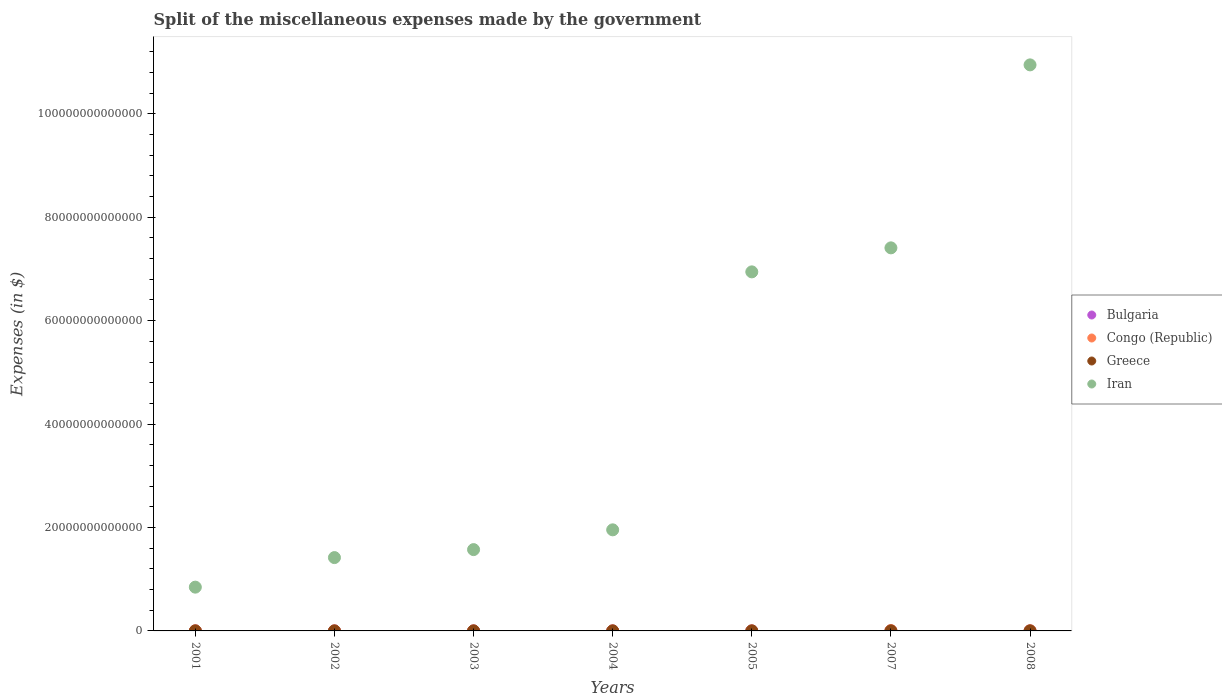What is the miscellaneous expenses made by the government in Congo (Republic) in 2005?
Offer a very short reply. 3.32e+08. Across all years, what is the maximum miscellaneous expenses made by the government in Congo (Republic)?
Your answer should be compact. 5.35e+1. Across all years, what is the minimum miscellaneous expenses made by the government in Bulgaria?
Keep it short and to the point. 1.15e+08. What is the total miscellaneous expenses made by the government in Bulgaria in the graph?
Provide a short and direct response. 3.72e+09. What is the difference between the miscellaneous expenses made by the government in Congo (Republic) in 2005 and that in 2008?
Make the answer very short. -1.84e+1. What is the difference between the miscellaneous expenses made by the government in Iran in 2007 and the miscellaneous expenses made by the government in Congo (Republic) in 2008?
Give a very brief answer. 7.41e+13. What is the average miscellaneous expenses made by the government in Congo (Republic) per year?
Provide a succinct answer. 1.38e+1. In the year 2002, what is the difference between the miscellaneous expenses made by the government in Congo (Republic) and miscellaneous expenses made by the government in Iran?
Offer a terse response. -1.42e+13. What is the ratio of the miscellaneous expenses made by the government in Bulgaria in 2003 to that in 2004?
Make the answer very short. 0.72. Is the difference between the miscellaneous expenses made by the government in Congo (Republic) in 2002 and 2004 greater than the difference between the miscellaneous expenses made by the government in Iran in 2002 and 2004?
Provide a succinct answer. Yes. What is the difference between the highest and the second highest miscellaneous expenses made by the government in Iran?
Give a very brief answer. 3.54e+13. What is the difference between the highest and the lowest miscellaneous expenses made by the government in Bulgaria?
Provide a succinct answer. 1.11e+09. In how many years, is the miscellaneous expenses made by the government in Greece greater than the average miscellaneous expenses made by the government in Greece taken over all years?
Provide a succinct answer. 3. Does the miscellaneous expenses made by the government in Congo (Republic) monotonically increase over the years?
Provide a short and direct response. No. Is the miscellaneous expenses made by the government in Greece strictly greater than the miscellaneous expenses made by the government in Congo (Republic) over the years?
Offer a very short reply. No. How many years are there in the graph?
Your answer should be very brief. 7. What is the difference between two consecutive major ticks on the Y-axis?
Provide a short and direct response. 2.00e+13. Does the graph contain any zero values?
Offer a very short reply. No. How many legend labels are there?
Keep it short and to the point. 4. What is the title of the graph?
Offer a terse response. Split of the miscellaneous expenses made by the government. What is the label or title of the Y-axis?
Your answer should be very brief. Expenses (in $). What is the Expenses (in $) in Bulgaria in 2001?
Offer a terse response. 1.15e+08. What is the Expenses (in $) in Congo (Republic) in 2001?
Offer a terse response. 1.96e+1. What is the Expenses (in $) of Greece in 2001?
Offer a terse response. 6.46e+09. What is the Expenses (in $) of Iran in 2001?
Your answer should be compact. 8.46e+12. What is the Expenses (in $) of Bulgaria in 2002?
Offer a very short reply. 2.27e+08. What is the Expenses (in $) in Congo (Republic) in 2002?
Your response must be concise. 2.75e+09. What is the Expenses (in $) in Greece in 2002?
Give a very brief answer. 5.64e+09. What is the Expenses (in $) in Iran in 2002?
Your answer should be compact. 1.42e+13. What is the Expenses (in $) of Bulgaria in 2003?
Provide a succinct answer. 2.76e+08. What is the Expenses (in $) in Congo (Republic) in 2003?
Offer a very short reply. 1.55e+09. What is the Expenses (in $) of Greece in 2003?
Keep it short and to the point. 6.39e+09. What is the Expenses (in $) of Iran in 2003?
Ensure brevity in your answer.  1.57e+13. What is the Expenses (in $) in Bulgaria in 2004?
Give a very brief answer. 3.84e+08. What is the Expenses (in $) of Congo (Republic) in 2004?
Offer a very short reply. 2.56e+08. What is the Expenses (in $) of Greece in 2004?
Give a very brief answer. 8.55e+09. What is the Expenses (in $) of Iran in 2004?
Offer a very short reply. 1.95e+13. What is the Expenses (in $) in Bulgaria in 2005?
Ensure brevity in your answer.  4.53e+08. What is the Expenses (in $) of Congo (Republic) in 2005?
Offer a terse response. 3.32e+08. What is the Expenses (in $) in Greece in 2005?
Ensure brevity in your answer.  6.98e+09. What is the Expenses (in $) of Iran in 2005?
Your answer should be very brief. 6.94e+13. What is the Expenses (in $) in Bulgaria in 2007?
Give a very brief answer. 1.05e+09. What is the Expenses (in $) in Congo (Republic) in 2007?
Make the answer very short. 5.35e+1. What is the Expenses (in $) in Greece in 2007?
Your response must be concise. 7.33e+09. What is the Expenses (in $) in Iran in 2007?
Make the answer very short. 7.41e+13. What is the Expenses (in $) of Bulgaria in 2008?
Ensure brevity in your answer.  1.22e+09. What is the Expenses (in $) of Congo (Republic) in 2008?
Offer a terse response. 1.88e+1. What is the Expenses (in $) of Greece in 2008?
Ensure brevity in your answer.  9.56e+09. What is the Expenses (in $) of Iran in 2008?
Offer a very short reply. 1.09e+14. Across all years, what is the maximum Expenses (in $) of Bulgaria?
Your answer should be compact. 1.22e+09. Across all years, what is the maximum Expenses (in $) of Congo (Republic)?
Your response must be concise. 5.35e+1. Across all years, what is the maximum Expenses (in $) of Greece?
Provide a succinct answer. 9.56e+09. Across all years, what is the maximum Expenses (in $) of Iran?
Your response must be concise. 1.09e+14. Across all years, what is the minimum Expenses (in $) of Bulgaria?
Give a very brief answer. 1.15e+08. Across all years, what is the minimum Expenses (in $) of Congo (Republic)?
Keep it short and to the point. 2.56e+08. Across all years, what is the minimum Expenses (in $) of Greece?
Your response must be concise. 5.64e+09. Across all years, what is the minimum Expenses (in $) in Iran?
Give a very brief answer. 8.46e+12. What is the total Expenses (in $) in Bulgaria in the graph?
Provide a succinct answer. 3.72e+09. What is the total Expenses (in $) of Congo (Republic) in the graph?
Offer a terse response. 9.68e+1. What is the total Expenses (in $) of Greece in the graph?
Your response must be concise. 5.09e+1. What is the total Expenses (in $) in Iran in the graph?
Keep it short and to the point. 3.11e+14. What is the difference between the Expenses (in $) in Bulgaria in 2001 and that in 2002?
Your response must be concise. -1.12e+08. What is the difference between the Expenses (in $) of Congo (Republic) in 2001 and that in 2002?
Give a very brief answer. 1.69e+1. What is the difference between the Expenses (in $) of Greece in 2001 and that in 2002?
Make the answer very short. 8.20e+08. What is the difference between the Expenses (in $) of Iran in 2001 and that in 2002?
Your response must be concise. -5.72e+12. What is the difference between the Expenses (in $) of Bulgaria in 2001 and that in 2003?
Ensure brevity in your answer.  -1.62e+08. What is the difference between the Expenses (in $) in Congo (Republic) in 2001 and that in 2003?
Your response must be concise. 1.81e+1. What is the difference between the Expenses (in $) in Greece in 2001 and that in 2003?
Ensure brevity in your answer.  7.70e+07. What is the difference between the Expenses (in $) in Iran in 2001 and that in 2003?
Offer a terse response. -7.26e+12. What is the difference between the Expenses (in $) in Bulgaria in 2001 and that in 2004?
Give a very brief answer. -2.70e+08. What is the difference between the Expenses (in $) in Congo (Republic) in 2001 and that in 2004?
Keep it short and to the point. 1.94e+1. What is the difference between the Expenses (in $) in Greece in 2001 and that in 2004?
Offer a terse response. -2.09e+09. What is the difference between the Expenses (in $) in Iran in 2001 and that in 2004?
Your answer should be very brief. -1.11e+13. What is the difference between the Expenses (in $) in Bulgaria in 2001 and that in 2005?
Your answer should be compact. -3.39e+08. What is the difference between the Expenses (in $) of Congo (Republic) in 2001 and that in 2005?
Keep it short and to the point. 1.93e+1. What is the difference between the Expenses (in $) in Greece in 2001 and that in 2005?
Provide a short and direct response. -5.20e+08. What is the difference between the Expenses (in $) in Iran in 2001 and that in 2005?
Ensure brevity in your answer.  -6.10e+13. What is the difference between the Expenses (in $) in Bulgaria in 2001 and that in 2007?
Offer a terse response. -9.34e+08. What is the difference between the Expenses (in $) in Congo (Republic) in 2001 and that in 2007?
Your answer should be very brief. -3.39e+1. What is the difference between the Expenses (in $) in Greece in 2001 and that in 2007?
Offer a terse response. -8.68e+08. What is the difference between the Expenses (in $) in Iran in 2001 and that in 2007?
Give a very brief answer. -6.56e+13. What is the difference between the Expenses (in $) of Bulgaria in 2001 and that in 2008?
Your response must be concise. -1.11e+09. What is the difference between the Expenses (in $) of Congo (Republic) in 2001 and that in 2008?
Offer a very short reply. 8.49e+08. What is the difference between the Expenses (in $) in Greece in 2001 and that in 2008?
Provide a succinct answer. -3.10e+09. What is the difference between the Expenses (in $) of Iran in 2001 and that in 2008?
Provide a short and direct response. -1.01e+14. What is the difference between the Expenses (in $) of Bulgaria in 2002 and that in 2003?
Provide a succinct answer. -4.91e+07. What is the difference between the Expenses (in $) in Congo (Republic) in 2002 and that in 2003?
Give a very brief answer. 1.20e+09. What is the difference between the Expenses (in $) of Greece in 2002 and that in 2003?
Provide a succinct answer. -7.43e+08. What is the difference between the Expenses (in $) in Iran in 2002 and that in 2003?
Your response must be concise. -1.54e+12. What is the difference between the Expenses (in $) of Bulgaria in 2002 and that in 2004?
Ensure brevity in your answer.  -1.57e+08. What is the difference between the Expenses (in $) in Congo (Republic) in 2002 and that in 2004?
Your response must be concise. 2.49e+09. What is the difference between the Expenses (in $) of Greece in 2002 and that in 2004?
Ensure brevity in your answer.  -2.91e+09. What is the difference between the Expenses (in $) of Iran in 2002 and that in 2004?
Your response must be concise. -5.37e+12. What is the difference between the Expenses (in $) in Bulgaria in 2002 and that in 2005?
Give a very brief answer. -2.26e+08. What is the difference between the Expenses (in $) in Congo (Republic) in 2002 and that in 2005?
Ensure brevity in your answer.  2.42e+09. What is the difference between the Expenses (in $) in Greece in 2002 and that in 2005?
Your answer should be very brief. -1.34e+09. What is the difference between the Expenses (in $) of Iran in 2002 and that in 2005?
Give a very brief answer. -5.52e+13. What is the difference between the Expenses (in $) in Bulgaria in 2002 and that in 2007?
Offer a terse response. -8.21e+08. What is the difference between the Expenses (in $) in Congo (Republic) in 2002 and that in 2007?
Provide a short and direct response. -5.08e+1. What is the difference between the Expenses (in $) in Greece in 2002 and that in 2007?
Your answer should be very brief. -1.69e+09. What is the difference between the Expenses (in $) in Iran in 2002 and that in 2007?
Keep it short and to the point. -5.99e+13. What is the difference between the Expenses (in $) of Bulgaria in 2002 and that in 2008?
Your answer should be compact. -9.94e+08. What is the difference between the Expenses (in $) in Congo (Republic) in 2002 and that in 2008?
Offer a terse response. -1.60e+1. What is the difference between the Expenses (in $) in Greece in 2002 and that in 2008?
Your answer should be very brief. -3.92e+09. What is the difference between the Expenses (in $) of Iran in 2002 and that in 2008?
Offer a terse response. -9.53e+13. What is the difference between the Expenses (in $) of Bulgaria in 2003 and that in 2004?
Offer a very short reply. -1.08e+08. What is the difference between the Expenses (in $) of Congo (Republic) in 2003 and that in 2004?
Make the answer very short. 1.29e+09. What is the difference between the Expenses (in $) in Greece in 2003 and that in 2004?
Offer a very short reply. -2.16e+09. What is the difference between the Expenses (in $) of Iran in 2003 and that in 2004?
Keep it short and to the point. -3.82e+12. What is the difference between the Expenses (in $) in Bulgaria in 2003 and that in 2005?
Provide a succinct answer. -1.77e+08. What is the difference between the Expenses (in $) in Congo (Republic) in 2003 and that in 2005?
Your response must be concise. 1.22e+09. What is the difference between the Expenses (in $) of Greece in 2003 and that in 2005?
Keep it short and to the point. -5.97e+08. What is the difference between the Expenses (in $) in Iran in 2003 and that in 2005?
Your response must be concise. -5.37e+13. What is the difference between the Expenses (in $) of Bulgaria in 2003 and that in 2007?
Your answer should be compact. -7.72e+08. What is the difference between the Expenses (in $) of Congo (Republic) in 2003 and that in 2007?
Ensure brevity in your answer.  -5.20e+1. What is the difference between the Expenses (in $) in Greece in 2003 and that in 2007?
Provide a short and direct response. -9.45e+08. What is the difference between the Expenses (in $) in Iran in 2003 and that in 2007?
Make the answer very short. -5.83e+13. What is the difference between the Expenses (in $) in Bulgaria in 2003 and that in 2008?
Provide a succinct answer. -9.45e+08. What is the difference between the Expenses (in $) of Congo (Republic) in 2003 and that in 2008?
Provide a succinct answer. -1.72e+1. What is the difference between the Expenses (in $) in Greece in 2003 and that in 2008?
Your answer should be very brief. -3.18e+09. What is the difference between the Expenses (in $) in Iran in 2003 and that in 2008?
Keep it short and to the point. -9.37e+13. What is the difference between the Expenses (in $) of Bulgaria in 2004 and that in 2005?
Offer a terse response. -6.90e+07. What is the difference between the Expenses (in $) of Congo (Republic) in 2004 and that in 2005?
Provide a succinct answer. -7.63e+07. What is the difference between the Expenses (in $) of Greece in 2004 and that in 2005?
Offer a terse response. 1.57e+09. What is the difference between the Expenses (in $) of Iran in 2004 and that in 2005?
Offer a very short reply. -4.99e+13. What is the difference between the Expenses (in $) of Bulgaria in 2004 and that in 2007?
Keep it short and to the point. -6.64e+08. What is the difference between the Expenses (in $) in Congo (Republic) in 2004 and that in 2007?
Your answer should be compact. -5.33e+1. What is the difference between the Expenses (in $) of Greece in 2004 and that in 2007?
Provide a succinct answer. 1.22e+09. What is the difference between the Expenses (in $) in Iran in 2004 and that in 2007?
Your response must be concise. -5.45e+13. What is the difference between the Expenses (in $) of Bulgaria in 2004 and that in 2008?
Offer a terse response. -8.37e+08. What is the difference between the Expenses (in $) of Congo (Republic) in 2004 and that in 2008?
Make the answer very short. -1.85e+1. What is the difference between the Expenses (in $) of Greece in 2004 and that in 2008?
Offer a terse response. -1.01e+09. What is the difference between the Expenses (in $) in Iran in 2004 and that in 2008?
Give a very brief answer. -8.99e+13. What is the difference between the Expenses (in $) in Bulgaria in 2005 and that in 2007?
Offer a very short reply. -5.95e+08. What is the difference between the Expenses (in $) in Congo (Republic) in 2005 and that in 2007?
Make the answer very short. -5.32e+1. What is the difference between the Expenses (in $) in Greece in 2005 and that in 2007?
Make the answer very short. -3.48e+08. What is the difference between the Expenses (in $) of Iran in 2005 and that in 2007?
Make the answer very short. -4.64e+12. What is the difference between the Expenses (in $) in Bulgaria in 2005 and that in 2008?
Give a very brief answer. -7.68e+08. What is the difference between the Expenses (in $) in Congo (Republic) in 2005 and that in 2008?
Offer a terse response. -1.84e+1. What is the difference between the Expenses (in $) in Greece in 2005 and that in 2008?
Make the answer very short. -2.58e+09. What is the difference between the Expenses (in $) of Iran in 2005 and that in 2008?
Your response must be concise. -4.00e+13. What is the difference between the Expenses (in $) of Bulgaria in 2007 and that in 2008?
Provide a succinct answer. -1.72e+08. What is the difference between the Expenses (in $) in Congo (Republic) in 2007 and that in 2008?
Make the answer very short. 3.48e+1. What is the difference between the Expenses (in $) of Greece in 2007 and that in 2008?
Your response must be concise. -2.23e+09. What is the difference between the Expenses (in $) in Iran in 2007 and that in 2008?
Offer a terse response. -3.54e+13. What is the difference between the Expenses (in $) of Bulgaria in 2001 and the Expenses (in $) of Congo (Republic) in 2002?
Provide a short and direct response. -2.63e+09. What is the difference between the Expenses (in $) in Bulgaria in 2001 and the Expenses (in $) in Greece in 2002?
Your answer should be very brief. -5.53e+09. What is the difference between the Expenses (in $) in Bulgaria in 2001 and the Expenses (in $) in Iran in 2002?
Give a very brief answer. -1.42e+13. What is the difference between the Expenses (in $) in Congo (Republic) in 2001 and the Expenses (in $) in Greece in 2002?
Your answer should be very brief. 1.40e+1. What is the difference between the Expenses (in $) in Congo (Republic) in 2001 and the Expenses (in $) in Iran in 2002?
Offer a terse response. -1.42e+13. What is the difference between the Expenses (in $) of Greece in 2001 and the Expenses (in $) of Iran in 2002?
Keep it short and to the point. -1.42e+13. What is the difference between the Expenses (in $) of Bulgaria in 2001 and the Expenses (in $) of Congo (Republic) in 2003?
Your response must be concise. -1.44e+09. What is the difference between the Expenses (in $) in Bulgaria in 2001 and the Expenses (in $) in Greece in 2003?
Keep it short and to the point. -6.27e+09. What is the difference between the Expenses (in $) in Bulgaria in 2001 and the Expenses (in $) in Iran in 2003?
Make the answer very short. -1.57e+13. What is the difference between the Expenses (in $) in Congo (Republic) in 2001 and the Expenses (in $) in Greece in 2003?
Your answer should be compact. 1.32e+1. What is the difference between the Expenses (in $) of Congo (Republic) in 2001 and the Expenses (in $) of Iran in 2003?
Make the answer very short. -1.57e+13. What is the difference between the Expenses (in $) of Greece in 2001 and the Expenses (in $) of Iran in 2003?
Ensure brevity in your answer.  -1.57e+13. What is the difference between the Expenses (in $) of Bulgaria in 2001 and the Expenses (in $) of Congo (Republic) in 2004?
Provide a succinct answer. -1.42e+08. What is the difference between the Expenses (in $) in Bulgaria in 2001 and the Expenses (in $) in Greece in 2004?
Give a very brief answer. -8.44e+09. What is the difference between the Expenses (in $) of Bulgaria in 2001 and the Expenses (in $) of Iran in 2004?
Keep it short and to the point. -1.95e+13. What is the difference between the Expenses (in $) of Congo (Republic) in 2001 and the Expenses (in $) of Greece in 2004?
Keep it short and to the point. 1.11e+1. What is the difference between the Expenses (in $) of Congo (Republic) in 2001 and the Expenses (in $) of Iran in 2004?
Ensure brevity in your answer.  -1.95e+13. What is the difference between the Expenses (in $) in Greece in 2001 and the Expenses (in $) in Iran in 2004?
Make the answer very short. -1.95e+13. What is the difference between the Expenses (in $) in Bulgaria in 2001 and the Expenses (in $) in Congo (Republic) in 2005?
Your response must be concise. -2.18e+08. What is the difference between the Expenses (in $) in Bulgaria in 2001 and the Expenses (in $) in Greece in 2005?
Provide a short and direct response. -6.87e+09. What is the difference between the Expenses (in $) of Bulgaria in 2001 and the Expenses (in $) of Iran in 2005?
Give a very brief answer. -6.94e+13. What is the difference between the Expenses (in $) of Congo (Republic) in 2001 and the Expenses (in $) of Greece in 2005?
Provide a succinct answer. 1.26e+1. What is the difference between the Expenses (in $) in Congo (Republic) in 2001 and the Expenses (in $) in Iran in 2005?
Your answer should be compact. -6.94e+13. What is the difference between the Expenses (in $) in Greece in 2001 and the Expenses (in $) in Iran in 2005?
Your response must be concise. -6.94e+13. What is the difference between the Expenses (in $) of Bulgaria in 2001 and the Expenses (in $) of Congo (Republic) in 2007?
Your answer should be compact. -5.34e+1. What is the difference between the Expenses (in $) of Bulgaria in 2001 and the Expenses (in $) of Greece in 2007?
Offer a terse response. -7.22e+09. What is the difference between the Expenses (in $) in Bulgaria in 2001 and the Expenses (in $) in Iran in 2007?
Provide a succinct answer. -7.41e+13. What is the difference between the Expenses (in $) of Congo (Republic) in 2001 and the Expenses (in $) of Greece in 2007?
Your response must be concise. 1.23e+1. What is the difference between the Expenses (in $) in Congo (Republic) in 2001 and the Expenses (in $) in Iran in 2007?
Provide a short and direct response. -7.41e+13. What is the difference between the Expenses (in $) of Greece in 2001 and the Expenses (in $) of Iran in 2007?
Your answer should be compact. -7.41e+13. What is the difference between the Expenses (in $) of Bulgaria in 2001 and the Expenses (in $) of Congo (Republic) in 2008?
Your answer should be very brief. -1.87e+1. What is the difference between the Expenses (in $) of Bulgaria in 2001 and the Expenses (in $) of Greece in 2008?
Provide a succinct answer. -9.45e+09. What is the difference between the Expenses (in $) in Bulgaria in 2001 and the Expenses (in $) in Iran in 2008?
Your answer should be compact. -1.09e+14. What is the difference between the Expenses (in $) in Congo (Republic) in 2001 and the Expenses (in $) in Greece in 2008?
Provide a short and direct response. 1.01e+1. What is the difference between the Expenses (in $) in Congo (Republic) in 2001 and the Expenses (in $) in Iran in 2008?
Your answer should be very brief. -1.09e+14. What is the difference between the Expenses (in $) of Greece in 2001 and the Expenses (in $) of Iran in 2008?
Your answer should be very brief. -1.09e+14. What is the difference between the Expenses (in $) of Bulgaria in 2002 and the Expenses (in $) of Congo (Republic) in 2003?
Your response must be concise. -1.32e+09. What is the difference between the Expenses (in $) in Bulgaria in 2002 and the Expenses (in $) in Greece in 2003?
Provide a succinct answer. -6.16e+09. What is the difference between the Expenses (in $) of Bulgaria in 2002 and the Expenses (in $) of Iran in 2003?
Your answer should be compact. -1.57e+13. What is the difference between the Expenses (in $) of Congo (Republic) in 2002 and the Expenses (in $) of Greece in 2003?
Provide a short and direct response. -3.64e+09. What is the difference between the Expenses (in $) in Congo (Republic) in 2002 and the Expenses (in $) in Iran in 2003?
Your response must be concise. -1.57e+13. What is the difference between the Expenses (in $) of Greece in 2002 and the Expenses (in $) of Iran in 2003?
Your answer should be compact. -1.57e+13. What is the difference between the Expenses (in $) in Bulgaria in 2002 and the Expenses (in $) in Congo (Republic) in 2004?
Your answer should be very brief. -2.92e+07. What is the difference between the Expenses (in $) of Bulgaria in 2002 and the Expenses (in $) of Greece in 2004?
Your answer should be very brief. -8.32e+09. What is the difference between the Expenses (in $) of Bulgaria in 2002 and the Expenses (in $) of Iran in 2004?
Your answer should be very brief. -1.95e+13. What is the difference between the Expenses (in $) in Congo (Republic) in 2002 and the Expenses (in $) in Greece in 2004?
Offer a terse response. -5.80e+09. What is the difference between the Expenses (in $) in Congo (Republic) in 2002 and the Expenses (in $) in Iran in 2004?
Your answer should be very brief. -1.95e+13. What is the difference between the Expenses (in $) of Greece in 2002 and the Expenses (in $) of Iran in 2004?
Provide a succinct answer. -1.95e+13. What is the difference between the Expenses (in $) of Bulgaria in 2002 and the Expenses (in $) of Congo (Republic) in 2005?
Give a very brief answer. -1.05e+08. What is the difference between the Expenses (in $) of Bulgaria in 2002 and the Expenses (in $) of Greece in 2005?
Offer a very short reply. -6.76e+09. What is the difference between the Expenses (in $) in Bulgaria in 2002 and the Expenses (in $) in Iran in 2005?
Make the answer very short. -6.94e+13. What is the difference between the Expenses (in $) of Congo (Republic) in 2002 and the Expenses (in $) of Greece in 2005?
Give a very brief answer. -4.23e+09. What is the difference between the Expenses (in $) in Congo (Republic) in 2002 and the Expenses (in $) in Iran in 2005?
Ensure brevity in your answer.  -6.94e+13. What is the difference between the Expenses (in $) in Greece in 2002 and the Expenses (in $) in Iran in 2005?
Your answer should be compact. -6.94e+13. What is the difference between the Expenses (in $) in Bulgaria in 2002 and the Expenses (in $) in Congo (Republic) in 2007?
Provide a short and direct response. -5.33e+1. What is the difference between the Expenses (in $) of Bulgaria in 2002 and the Expenses (in $) of Greece in 2007?
Make the answer very short. -7.10e+09. What is the difference between the Expenses (in $) of Bulgaria in 2002 and the Expenses (in $) of Iran in 2007?
Keep it short and to the point. -7.41e+13. What is the difference between the Expenses (in $) of Congo (Republic) in 2002 and the Expenses (in $) of Greece in 2007?
Your answer should be very brief. -4.58e+09. What is the difference between the Expenses (in $) in Congo (Republic) in 2002 and the Expenses (in $) in Iran in 2007?
Your answer should be compact. -7.41e+13. What is the difference between the Expenses (in $) in Greece in 2002 and the Expenses (in $) in Iran in 2007?
Offer a terse response. -7.41e+13. What is the difference between the Expenses (in $) of Bulgaria in 2002 and the Expenses (in $) of Congo (Republic) in 2008?
Your answer should be very brief. -1.85e+1. What is the difference between the Expenses (in $) of Bulgaria in 2002 and the Expenses (in $) of Greece in 2008?
Provide a short and direct response. -9.34e+09. What is the difference between the Expenses (in $) in Bulgaria in 2002 and the Expenses (in $) in Iran in 2008?
Provide a succinct answer. -1.09e+14. What is the difference between the Expenses (in $) in Congo (Republic) in 2002 and the Expenses (in $) in Greece in 2008?
Your response must be concise. -6.81e+09. What is the difference between the Expenses (in $) of Congo (Republic) in 2002 and the Expenses (in $) of Iran in 2008?
Offer a very short reply. -1.09e+14. What is the difference between the Expenses (in $) of Greece in 2002 and the Expenses (in $) of Iran in 2008?
Provide a succinct answer. -1.09e+14. What is the difference between the Expenses (in $) in Bulgaria in 2003 and the Expenses (in $) in Congo (Republic) in 2004?
Provide a short and direct response. 1.99e+07. What is the difference between the Expenses (in $) of Bulgaria in 2003 and the Expenses (in $) of Greece in 2004?
Your response must be concise. -8.27e+09. What is the difference between the Expenses (in $) of Bulgaria in 2003 and the Expenses (in $) of Iran in 2004?
Offer a terse response. -1.95e+13. What is the difference between the Expenses (in $) of Congo (Republic) in 2003 and the Expenses (in $) of Greece in 2004?
Provide a short and direct response. -7.00e+09. What is the difference between the Expenses (in $) of Congo (Republic) in 2003 and the Expenses (in $) of Iran in 2004?
Make the answer very short. -1.95e+13. What is the difference between the Expenses (in $) in Greece in 2003 and the Expenses (in $) in Iran in 2004?
Ensure brevity in your answer.  -1.95e+13. What is the difference between the Expenses (in $) in Bulgaria in 2003 and the Expenses (in $) in Congo (Republic) in 2005?
Your answer should be very brief. -5.64e+07. What is the difference between the Expenses (in $) of Bulgaria in 2003 and the Expenses (in $) of Greece in 2005?
Your answer should be very brief. -6.71e+09. What is the difference between the Expenses (in $) in Bulgaria in 2003 and the Expenses (in $) in Iran in 2005?
Make the answer very short. -6.94e+13. What is the difference between the Expenses (in $) in Congo (Republic) in 2003 and the Expenses (in $) in Greece in 2005?
Your response must be concise. -5.43e+09. What is the difference between the Expenses (in $) of Congo (Republic) in 2003 and the Expenses (in $) of Iran in 2005?
Your response must be concise. -6.94e+13. What is the difference between the Expenses (in $) in Greece in 2003 and the Expenses (in $) in Iran in 2005?
Provide a short and direct response. -6.94e+13. What is the difference between the Expenses (in $) of Bulgaria in 2003 and the Expenses (in $) of Congo (Republic) in 2007?
Ensure brevity in your answer.  -5.33e+1. What is the difference between the Expenses (in $) of Bulgaria in 2003 and the Expenses (in $) of Greece in 2007?
Offer a very short reply. -7.06e+09. What is the difference between the Expenses (in $) in Bulgaria in 2003 and the Expenses (in $) in Iran in 2007?
Provide a succinct answer. -7.41e+13. What is the difference between the Expenses (in $) of Congo (Republic) in 2003 and the Expenses (in $) of Greece in 2007?
Offer a terse response. -5.78e+09. What is the difference between the Expenses (in $) of Congo (Republic) in 2003 and the Expenses (in $) of Iran in 2007?
Your response must be concise. -7.41e+13. What is the difference between the Expenses (in $) of Greece in 2003 and the Expenses (in $) of Iran in 2007?
Your response must be concise. -7.41e+13. What is the difference between the Expenses (in $) in Bulgaria in 2003 and the Expenses (in $) in Congo (Republic) in 2008?
Give a very brief answer. -1.85e+1. What is the difference between the Expenses (in $) of Bulgaria in 2003 and the Expenses (in $) of Greece in 2008?
Provide a short and direct response. -9.29e+09. What is the difference between the Expenses (in $) in Bulgaria in 2003 and the Expenses (in $) in Iran in 2008?
Keep it short and to the point. -1.09e+14. What is the difference between the Expenses (in $) in Congo (Republic) in 2003 and the Expenses (in $) in Greece in 2008?
Give a very brief answer. -8.01e+09. What is the difference between the Expenses (in $) of Congo (Republic) in 2003 and the Expenses (in $) of Iran in 2008?
Offer a terse response. -1.09e+14. What is the difference between the Expenses (in $) in Greece in 2003 and the Expenses (in $) in Iran in 2008?
Make the answer very short. -1.09e+14. What is the difference between the Expenses (in $) of Bulgaria in 2004 and the Expenses (in $) of Congo (Republic) in 2005?
Make the answer very short. 5.16e+07. What is the difference between the Expenses (in $) of Bulgaria in 2004 and the Expenses (in $) of Greece in 2005?
Provide a short and direct response. -6.60e+09. What is the difference between the Expenses (in $) of Bulgaria in 2004 and the Expenses (in $) of Iran in 2005?
Keep it short and to the point. -6.94e+13. What is the difference between the Expenses (in $) of Congo (Republic) in 2004 and the Expenses (in $) of Greece in 2005?
Provide a succinct answer. -6.73e+09. What is the difference between the Expenses (in $) in Congo (Republic) in 2004 and the Expenses (in $) in Iran in 2005?
Provide a succinct answer. -6.94e+13. What is the difference between the Expenses (in $) of Greece in 2004 and the Expenses (in $) of Iran in 2005?
Give a very brief answer. -6.94e+13. What is the difference between the Expenses (in $) in Bulgaria in 2004 and the Expenses (in $) in Congo (Republic) in 2007?
Give a very brief answer. -5.31e+1. What is the difference between the Expenses (in $) in Bulgaria in 2004 and the Expenses (in $) in Greece in 2007?
Your response must be concise. -6.95e+09. What is the difference between the Expenses (in $) of Bulgaria in 2004 and the Expenses (in $) of Iran in 2007?
Your answer should be very brief. -7.41e+13. What is the difference between the Expenses (in $) in Congo (Republic) in 2004 and the Expenses (in $) in Greece in 2007?
Your response must be concise. -7.08e+09. What is the difference between the Expenses (in $) in Congo (Republic) in 2004 and the Expenses (in $) in Iran in 2007?
Your answer should be very brief. -7.41e+13. What is the difference between the Expenses (in $) in Greece in 2004 and the Expenses (in $) in Iran in 2007?
Your response must be concise. -7.41e+13. What is the difference between the Expenses (in $) in Bulgaria in 2004 and the Expenses (in $) in Congo (Republic) in 2008?
Your answer should be compact. -1.84e+1. What is the difference between the Expenses (in $) in Bulgaria in 2004 and the Expenses (in $) in Greece in 2008?
Provide a succinct answer. -9.18e+09. What is the difference between the Expenses (in $) in Bulgaria in 2004 and the Expenses (in $) in Iran in 2008?
Make the answer very short. -1.09e+14. What is the difference between the Expenses (in $) in Congo (Republic) in 2004 and the Expenses (in $) in Greece in 2008?
Your response must be concise. -9.31e+09. What is the difference between the Expenses (in $) in Congo (Republic) in 2004 and the Expenses (in $) in Iran in 2008?
Provide a short and direct response. -1.09e+14. What is the difference between the Expenses (in $) in Greece in 2004 and the Expenses (in $) in Iran in 2008?
Provide a succinct answer. -1.09e+14. What is the difference between the Expenses (in $) in Bulgaria in 2005 and the Expenses (in $) in Congo (Republic) in 2007?
Keep it short and to the point. -5.31e+1. What is the difference between the Expenses (in $) in Bulgaria in 2005 and the Expenses (in $) in Greece in 2007?
Give a very brief answer. -6.88e+09. What is the difference between the Expenses (in $) in Bulgaria in 2005 and the Expenses (in $) in Iran in 2007?
Keep it short and to the point. -7.41e+13. What is the difference between the Expenses (in $) in Congo (Republic) in 2005 and the Expenses (in $) in Greece in 2007?
Give a very brief answer. -7.00e+09. What is the difference between the Expenses (in $) in Congo (Republic) in 2005 and the Expenses (in $) in Iran in 2007?
Provide a succinct answer. -7.41e+13. What is the difference between the Expenses (in $) in Greece in 2005 and the Expenses (in $) in Iran in 2007?
Your answer should be compact. -7.41e+13. What is the difference between the Expenses (in $) in Bulgaria in 2005 and the Expenses (in $) in Congo (Republic) in 2008?
Offer a very short reply. -1.83e+1. What is the difference between the Expenses (in $) in Bulgaria in 2005 and the Expenses (in $) in Greece in 2008?
Provide a succinct answer. -9.11e+09. What is the difference between the Expenses (in $) in Bulgaria in 2005 and the Expenses (in $) in Iran in 2008?
Give a very brief answer. -1.09e+14. What is the difference between the Expenses (in $) of Congo (Republic) in 2005 and the Expenses (in $) of Greece in 2008?
Ensure brevity in your answer.  -9.23e+09. What is the difference between the Expenses (in $) in Congo (Republic) in 2005 and the Expenses (in $) in Iran in 2008?
Provide a succinct answer. -1.09e+14. What is the difference between the Expenses (in $) in Greece in 2005 and the Expenses (in $) in Iran in 2008?
Provide a short and direct response. -1.09e+14. What is the difference between the Expenses (in $) in Bulgaria in 2007 and the Expenses (in $) in Congo (Republic) in 2008?
Your answer should be very brief. -1.77e+1. What is the difference between the Expenses (in $) of Bulgaria in 2007 and the Expenses (in $) of Greece in 2008?
Keep it short and to the point. -8.51e+09. What is the difference between the Expenses (in $) of Bulgaria in 2007 and the Expenses (in $) of Iran in 2008?
Your answer should be compact. -1.09e+14. What is the difference between the Expenses (in $) of Congo (Republic) in 2007 and the Expenses (in $) of Greece in 2008?
Your answer should be very brief. 4.40e+1. What is the difference between the Expenses (in $) of Congo (Republic) in 2007 and the Expenses (in $) of Iran in 2008?
Provide a short and direct response. -1.09e+14. What is the difference between the Expenses (in $) in Greece in 2007 and the Expenses (in $) in Iran in 2008?
Make the answer very short. -1.09e+14. What is the average Expenses (in $) in Bulgaria per year?
Your answer should be very brief. 5.32e+08. What is the average Expenses (in $) in Congo (Republic) per year?
Your response must be concise. 1.38e+1. What is the average Expenses (in $) of Greece per year?
Offer a terse response. 7.27e+09. What is the average Expenses (in $) in Iran per year?
Ensure brevity in your answer.  4.44e+13. In the year 2001, what is the difference between the Expenses (in $) in Bulgaria and Expenses (in $) in Congo (Republic)?
Give a very brief answer. -1.95e+1. In the year 2001, what is the difference between the Expenses (in $) in Bulgaria and Expenses (in $) in Greece?
Offer a very short reply. -6.35e+09. In the year 2001, what is the difference between the Expenses (in $) in Bulgaria and Expenses (in $) in Iran?
Your answer should be compact. -8.46e+12. In the year 2001, what is the difference between the Expenses (in $) in Congo (Republic) and Expenses (in $) in Greece?
Keep it short and to the point. 1.32e+1. In the year 2001, what is the difference between the Expenses (in $) of Congo (Republic) and Expenses (in $) of Iran?
Ensure brevity in your answer.  -8.44e+12. In the year 2001, what is the difference between the Expenses (in $) of Greece and Expenses (in $) of Iran?
Your response must be concise. -8.46e+12. In the year 2002, what is the difference between the Expenses (in $) of Bulgaria and Expenses (in $) of Congo (Republic)?
Provide a short and direct response. -2.52e+09. In the year 2002, what is the difference between the Expenses (in $) in Bulgaria and Expenses (in $) in Greece?
Provide a succinct answer. -5.42e+09. In the year 2002, what is the difference between the Expenses (in $) of Bulgaria and Expenses (in $) of Iran?
Ensure brevity in your answer.  -1.42e+13. In the year 2002, what is the difference between the Expenses (in $) of Congo (Republic) and Expenses (in $) of Greece?
Ensure brevity in your answer.  -2.89e+09. In the year 2002, what is the difference between the Expenses (in $) in Congo (Republic) and Expenses (in $) in Iran?
Keep it short and to the point. -1.42e+13. In the year 2002, what is the difference between the Expenses (in $) of Greece and Expenses (in $) of Iran?
Ensure brevity in your answer.  -1.42e+13. In the year 2003, what is the difference between the Expenses (in $) of Bulgaria and Expenses (in $) of Congo (Republic)?
Keep it short and to the point. -1.27e+09. In the year 2003, what is the difference between the Expenses (in $) in Bulgaria and Expenses (in $) in Greece?
Make the answer very short. -6.11e+09. In the year 2003, what is the difference between the Expenses (in $) of Bulgaria and Expenses (in $) of Iran?
Offer a terse response. -1.57e+13. In the year 2003, what is the difference between the Expenses (in $) of Congo (Republic) and Expenses (in $) of Greece?
Your answer should be very brief. -4.84e+09. In the year 2003, what is the difference between the Expenses (in $) in Congo (Republic) and Expenses (in $) in Iran?
Offer a terse response. -1.57e+13. In the year 2003, what is the difference between the Expenses (in $) of Greece and Expenses (in $) of Iran?
Offer a very short reply. -1.57e+13. In the year 2004, what is the difference between the Expenses (in $) of Bulgaria and Expenses (in $) of Congo (Republic)?
Offer a terse response. 1.28e+08. In the year 2004, what is the difference between the Expenses (in $) of Bulgaria and Expenses (in $) of Greece?
Your answer should be very brief. -8.17e+09. In the year 2004, what is the difference between the Expenses (in $) of Bulgaria and Expenses (in $) of Iran?
Offer a terse response. -1.95e+13. In the year 2004, what is the difference between the Expenses (in $) in Congo (Republic) and Expenses (in $) in Greece?
Your answer should be compact. -8.29e+09. In the year 2004, what is the difference between the Expenses (in $) of Congo (Republic) and Expenses (in $) of Iran?
Offer a terse response. -1.95e+13. In the year 2004, what is the difference between the Expenses (in $) of Greece and Expenses (in $) of Iran?
Your answer should be compact. -1.95e+13. In the year 2005, what is the difference between the Expenses (in $) of Bulgaria and Expenses (in $) of Congo (Republic)?
Offer a very short reply. 1.21e+08. In the year 2005, what is the difference between the Expenses (in $) in Bulgaria and Expenses (in $) in Greece?
Provide a succinct answer. -6.53e+09. In the year 2005, what is the difference between the Expenses (in $) of Bulgaria and Expenses (in $) of Iran?
Offer a very short reply. -6.94e+13. In the year 2005, what is the difference between the Expenses (in $) of Congo (Republic) and Expenses (in $) of Greece?
Provide a short and direct response. -6.65e+09. In the year 2005, what is the difference between the Expenses (in $) in Congo (Republic) and Expenses (in $) in Iran?
Make the answer very short. -6.94e+13. In the year 2005, what is the difference between the Expenses (in $) in Greece and Expenses (in $) in Iran?
Ensure brevity in your answer.  -6.94e+13. In the year 2007, what is the difference between the Expenses (in $) in Bulgaria and Expenses (in $) in Congo (Republic)?
Provide a short and direct response. -5.25e+1. In the year 2007, what is the difference between the Expenses (in $) of Bulgaria and Expenses (in $) of Greece?
Offer a very short reply. -6.28e+09. In the year 2007, what is the difference between the Expenses (in $) in Bulgaria and Expenses (in $) in Iran?
Provide a succinct answer. -7.41e+13. In the year 2007, what is the difference between the Expenses (in $) in Congo (Republic) and Expenses (in $) in Greece?
Your response must be concise. 4.62e+1. In the year 2007, what is the difference between the Expenses (in $) of Congo (Republic) and Expenses (in $) of Iran?
Offer a very short reply. -7.40e+13. In the year 2007, what is the difference between the Expenses (in $) of Greece and Expenses (in $) of Iran?
Your response must be concise. -7.41e+13. In the year 2008, what is the difference between the Expenses (in $) in Bulgaria and Expenses (in $) in Congo (Republic)?
Make the answer very short. -1.75e+1. In the year 2008, what is the difference between the Expenses (in $) in Bulgaria and Expenses (in $) in Greece?
Your answer should be very brief. -8.34e+09. In the year 2008, what is the difference between the Expenses (in $) of Bulgaria and Expenses (in $) of Iran?
Your answer should be compact. -1.09e+14. In the year 2008, what is the difference between the Expenses (in $) of Congo (Republic) and Expenses (in $) of Greece?
Offer a terse response. 9.20e+09. In the year 2008, what is the difference between the Expenses (in $) in Congo (Republic) and Expenses (in $) in Iran?
Offer a terse response. -1.09e+14. In the year 2008, what is the difference between the Expenses (in $) in Greece and Expenses (in $) in Iran?
Offer a very short reply. -1.09e+14. What is the ratio of the Expenses (in $) of Bulgaria in 2001 to that in 2002?
Offer a terse response. 0.5. What is the ratio of the Expenses (in $) of Congo (Republic) in 2001 to that in 2002?
Your response must be concise. 7.13. What is the ratio of the Expenses (in $) of Greece in 2001 to that in 2002?
Offer a terse response. 1.15. What is the ratio of the Expenses (in $) of Iran in 2001 to that in 2002?
Offer a terse response. 0.6. What is the ratio of the Expenses (in $) in Bulgaria in 2001 to that in 2003?
Offer a terse response. 0.41. What is the ratio of the Expenses (in $) of Congo (Republic) in 2001 to that in 2003?
Your response must be concise. 12.66. What is the ratio of the Expenses (in $) in Greece in 2001 to that in 2003?
Keep it short and to the point. 1.01. What is the ratio of the Expenses (in $) of Iran in 2001 to that in 2003?
Ensure brevity in your answer.  0.54. What is the ratio of the Expenses (in $) of Bulgaria in 2001 to that in 2004?
Your answer should be very brief. 0.3. What is the ratio of the Expenses (in $) in Congo (Republic) in 2001 to that in 2004?
Ensure brevity in your answer.  76.55. What is the ratio of the Expenses (in $) in Greece in 2001 to that in 2004?
Keep it short and to the point. 0.76. What is the ratio of the Expenses (in $) of Iran in 2001 to that in 2004?
Your answer should be compact. 0.43. What is the ratio of the Expenses (in $) in Bulgaria in 2001 to that in 2005?
Offer a very short reply. 0.25. What is the ratio of the Expenses (in $) in Congo (Republic) in 2001 to that in 2005?
Ensure brevity in your answer.  58.99. What is the ratio of the Expenses (in $) of Greece in 2001 to that in 2005?
Provide a succinct answer. 0.93. What is the ratio of the Expenses (in $) in Iran in 2001 to that in 2005?
Keep it short and to the point. 0.12. What is the ratio of the Expenses (in $) of Bulgaria in 2001 to that in 2007?
Provide a short and direct response. 0.11. What is the ratio of the Expenses (in $) of Congo (Republic) in 2001 to that in 2007?
Your answer should be very brief. 0.37. What is the ratio of the Expenses (in $) in Greece in 2001 to that in 2007?
Offer a very short reply. 0.88. What is the ratio of the Expenses (in $) in Iran in 2001 to that in 2007?
Offer a terse response. 0.11. What is the ratio of the Expenses (in $) in Bulgaria in 2001 to that in 2008?
Keep it short and to the point. 0.09. What is the ratio of the Expenses (in $) in Congo (Republic) in 2001 to that in 2008?
Provide a succinct answer. 1.05. What is the ratio of the Expenses (in $) in Greece in 2001 to that in 2008?
Offer a terse response. 0.68. What is the ratio of the Expenses (in $) in Iran in 2001 to that in 2008?
Your answer should be very brief. 0.08. What is the ratio of the Expenses (in $) of Bulgaria in 2002 to that in 2003?
Your answer should be very brief. 0.82. What is the ratio of the Expenses (in $) in Congo (Republic) in 2002 to that in 2003?
Your answer should be compact. 1.77. What is the ratio of the Expenses (in $) of Greece in 2002 to that in 2003?
Your answer should be very brief. 0.88. What is the ratio of the Expenses (in $) in Iran in 2002 to that in 2003?
Offer a very short reply. 0.9. What is the ratio of the Expenses (in $) of Bulgaria in 2002 to that in 2004?
Your answer should be very brief. 0.59. What is the ratio of the Expenses (in $) of Congo (Republic) in 2002 to that in 2004?
Ensure brevity in your answer.  10.73. What is the ratio of the Expenses (in $) in Greece in 2002 to that in 2004?
Your answer should be very brief. 0.66. What is the ratio of the Expenses (in $) in Iran in 2002 to that in 2004?
Keep it short and to the point. 0.73. What is the ratio of the Expenses (in $) of Bulgaria in 2002 to that in 2005?
Give a very brief answer. 0.5. What is the ratio of the Expenses (in $) of Congo (Republic) in 2002 to that in 2005?
Your response must be concise. 8.27. What is the ratio of the Expenses (in $) in Greece in 2002 to that in 2005?
Make the answer very short. 0.81. What is the ratio of the Expenses (in $) of Iran in 2002 to that in 2005?
Provide a short and direct response. 0.2. What is the ratio of the Expenses (in $) of Bulgaria in 2002 to that in 2007?
Keep it short and to the point. 0.22. What is the ratio of the Expenses (in $) of Congo (Republic) in 2002 to that in 2007?
Provide a succinct answer. 0.05. What is the ratio of the Expenses (in $) in Greece in 2002 to that in 2007?
Ensure brevity in your answer.  0.77. What is the ratio of the Expenses (in $) of Iran in 2002 to that in 2007?
Your answer should be compact. 0.19. What is the ratio of the Expenses (in $) of Bulgaria in 2002 to that in 2008?
Offer a very short reply. 0.19. What is the ratio of the Expenses (in $) in Congo (Republic) in 2002 to that in 2008?
Offer a terse response. 0.15. What is the ratio of the Expenses (in $) of Greece in 2002 to that in 2008?
Provide a succinct answer. 0.59. What is the ratio of the Expenses (in $) of Iran in 2002 to that in 2008?
Provide a succinct answer. 0.13. What is the ratio of the Expenses (in $) of Bulgaria in 2003 to that in 2004?
Make the answer very short. 0.72. What is the ratio of the Expenses (in $) in Congo (Republic) in 2003 to that in 2004?
Offer a terse response. 6.05. What is the ratio of the Expenses (in $) of Greece in 2003 to that in 2004?
Offer a terse response. 0.75. What is the ratio of the Expenses (in $) in Iran in 2003 to that in 2004?
Your answer should be compact. 0.8. What is the ratio of the Expenses (in $) of Bulgaria in 2003 to that in 2005?
Provide a succinct answer. 0.61. What is the ratio of the Expenses (in $) of Congo (Republic) in 2003 to that in 2005?
Provide a succinct answer. 4.66. What is the ratio of the Expenses (in $) in Greece in 2003 to that in 2005?
Provide a short and direct response. 0.91. What is the ratio of the Expenses (in $) in Iran in 2003 to that in 2005?
Your answer should be compact. 0.23. What is the ratio of the Expenses (in $) in Bulgaria in 2003 to that in 2007?
Provide a short and direct response. 0.26. What is the ratio of the Expenses (in $) of Congo (Republic) in 2003 to that in 2007?
Make the answer very short. 0.03. What is the ratio of the Expenses (in $) of Greece in 2003 to that in 2007?
Your response must be concise. 0.87. What is the ratio of the Expenses (in $) of Iran in 2003 to that in 2007?
Offer a very short reply. 0.21. What is the ratio of the Expenses (in $) in Bulgaria in 2003 to that in 2008?
Make the answer very short. 0.23. What is the ratio of the Expenses (in $) in Congo (Republic) in 2003 to that in 2008?
Make the answer very short. 0.08. What is the ratio of the Expenses (in $) of Greece in 2003 to that in 2008?
Your response must be concise. 0.67. What is the ratio of the Expenses (in $) in Iran in 2003 to that in 2008?
Your response must be concise. 0.14. What is the ratio of the Expenses (in $) of Bulgaria in 2004 to that in 2005?
Offer a terse response. 0.85. What is the ratio of the Expenses (in $) in Congo (Republic) in 2004 to that in 2005?
Make the answer very short. 0.77. What is the ratio of the Expenses (in $) of Greece in 2004 to that in 2005?
Your answer should be compact. 1.22. What is the ratio of the Expenses (in $) in Iran in 2004 to that in 2005?
Keep it short and to the point. 0.28. What is the ratio of the Expenses (in $) in Bulgaria in 2004 to that in 2007?
Keep it short and to the point. 0.37. What is the ratio of the Expenses (in $) in Congo (Republic) in 2004 to that in 2007?
Offer a very short reply. 0. What is the ratio of the Expenses (in $) of Greece in 2004 to that in 2007?
Ensure brevity in your answer.  1.17. What is the ratio of the Expenses (in $) of Iran in 2004 to that in 2007?
Keep it short and to the point. 0.26. What is the ratio of the Expenses (in $) in Bulgaria in 2004 to that in 2008?
Provide a succinct answer. 0.31. What is the ratio of the Expenses (in $) in Congo (Republic) in 2004 to that in 2008?
Ensure brevity in your answer.  0.01. What is the ratio of the Expenses (in $) in Greece in 2004 to that in 2008?
Give a very brief answer. 0.89. What is the ratio of the Expenses (in $) in Iran in 2004 to that in 2008?
Keep it short and to the point. 0.18. What is the ratio of the Expenses (in $) in Bulgaria in 2005 to that in 2007?
Your answer should be compact. 0.43. What is the ratio of the Expenses (in $) of Congo (Republic) in 2005 to that in 2007?
Provide a short and direct response. 0.01. What is the ratio of the Expenses (in $) in Greece in 2005 to that in 2007?
Provide a short and direct response. 0.95. What is the ratio of the Expenses (in $) of Iran in 2005 to that in 2007?
Keep it short and to the point. 0.94. What is the ratio of the Expenses (in $) in Bulgaria in 2005 to that in 2008?
Your answer should be compact. 0.37. What is the ratio of the Expenses (in $) in Congo (Republic) in 2005 to that in 2008?
Offer a terse response. 0.02. What is the ratio of the Expenses (in $) of Greece in 2005 to that in 2008?
Your answer should be very brief. 0.73. What is the ratio of the Expenses (in $) in Iran in 2005 to that in 2008?
Offer a terse response. 0.63. What is the ratio of the Expenses (in $) of Bulgaria in 2007 to that in 2008?
Give a very brief answer. 0.86. What is the ratio of the Expenses (in $) in Congo (Republic) in 2007 to that in 2008?
Your response must be concise. 2.85. What is the ratio of the Expenses (in $) in Greece in 2007 to that in 2008?
Make the answer very short. 0.77. What is the ratio of the Expenses (in $) in Iran in 2007 to that in 2008?
Offer a terse response. 0.68. What is the difference between the highest and the second highest Expenses (in $) in Bulgaria?
Keep it short and to the point. 1.72e+08. What is the difference between the highest and the second highest Expenses (in $) in Congo (Republic)?
Offer a very short reply. 3.39e+1. What is the difference between the highest and the second highest Expenses (in $) of Greece?
Keep it short and to the point. 1.01e+09. What is the difference between the highest and the second highest Expenses (in $) in Iran?
Your answer should be compact. 3.54e+13. What is the difference between the highest and the lowest Expenses (in $) of Bulgaria?
Provide a succinct answer. 1.11e+09. What is the difference between the highest and the lowest Expenses (in $) in Congo (Republic)?
Make the answer very short. 5.33e+1. What is the difference between the highest and the lowest Expenses (in $) in Greece?
Your answer should be very brief. 3.92e+09. What is the difference between the highest and the lowest Expenses (in $) in Iran?
Provide a succinct answer. 1.01e+14. 